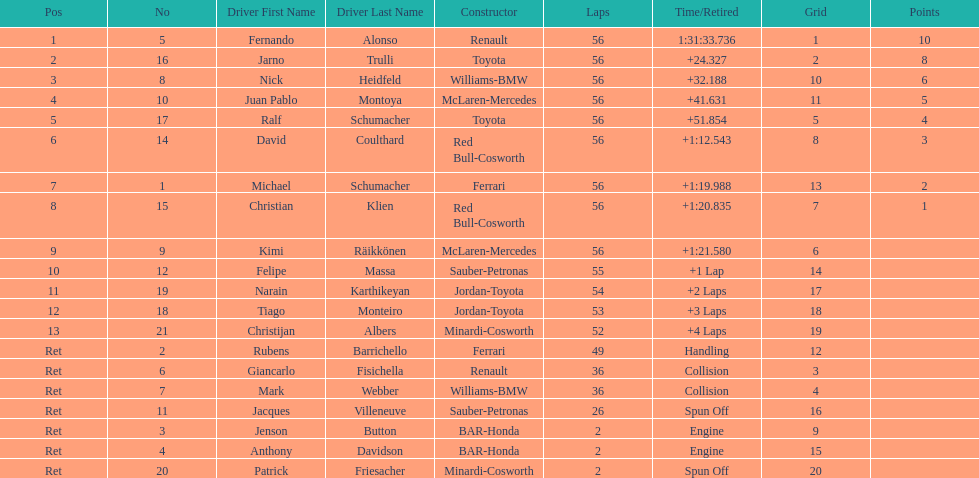Who finished before nick heidfeld? Jarno Trulli. 